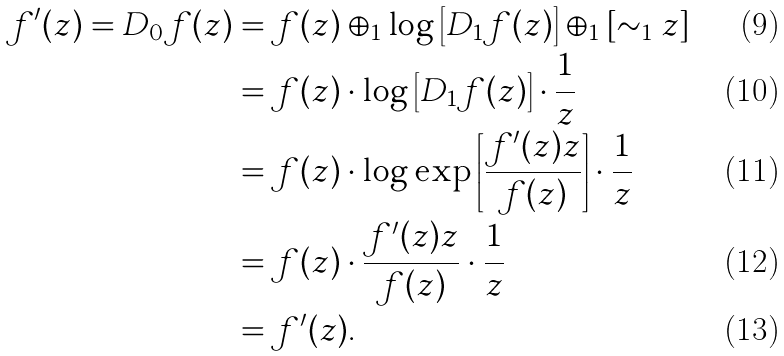Convert formula to latex. <formula><loc_0><loc_0><loc_500><loc_500>f ^ { \prime } ( z ) = D _ { 0 } f ( z ) & = f ( z ) \oplus _ { 1 } \log \left [ D _ { 1 } f ( z ) \right ] \oplus _ { 1 } [ \sim _ { 1 } z ] \\ & = f ( z ) \cdot \log \left [ D _ { 1 } f ( z ) \right ] \cdot \frac { 1 } { z } \\ & = f ( z ) \cdot \log \exp \left [ \frac { f ^ { \prime } ( z ) z } { f ( z ) } \right ] \cdot \frac { 1 } { z } \\ & = f ( z ) \cdot \frac { f ^ { \prime } ( z ) z } { f ( z ) } \cdot \frac { 1 } { z } \\ & = f ^ { \prime } ( z ) .</formula> 